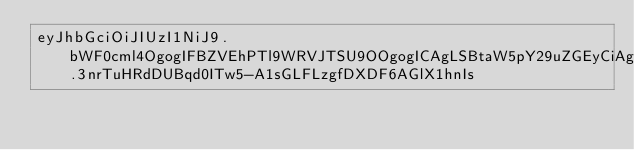<code> <loc_0><loc_0><loc_500><loc_500><_SML_>eyJhbGciOiJIUzI1NiJ9.bWF0cml4OgogIFBZVEhPTl9WRVJTSU9OOgogICAgLSBtaW5pY29uZGEyCiAgICAtIG1pbmljb25kYTMKCnBpcGVsaW5lOgogIGJ1aWxkOgogICAgaW1hZ2U6IGtzenVjcy8ke1BZVEhPTl9WRVJTSU9OfQogICAgY29tbWFuZHM6CiAgICAgIC0gcHl0aG9uIHNldHVwLnB5IHRlc3QKCiAgZGVwbG95OgogICAgaW1hZ2U6IHBsdWdpbnMvZHJvbmUtcHlwaQogICAgcmVwb3NpdG9yeTogaHR0cHM6Ly9weXBpLnB5dGhvbi5vcmcvcHlwaQogICAgdXNlcm5hbWU6ICQkUFlQSV9VU0VSTkFNRQogICAgcGFzc3dvcmQ6ICQkUFlQSV9QQVNTV09SRAogICAgZGlzdHJpYnV0aW9uczoKICAgICAgLSBzZGlzdAogICAgICAtIGJkaXN0X3doZWVsCiAgICB3aGVuOgogICAgICBldmVudDogW3RhZ10K.3nrTuHRdDUBqd0ITw5-A1sGLFLzgfDXDF6AGlX1hnIs</code> 